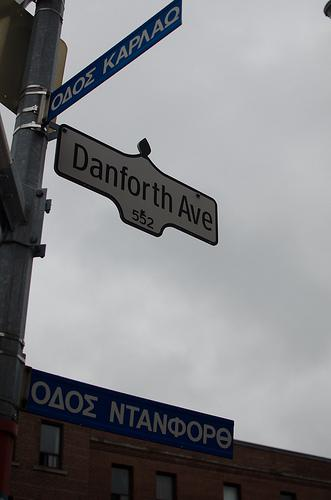Question: how many signs are there?
Choices:
A. One.
B. Two.
C. Three.
D. Four.
Answer with the letter. Answer: C Question: what number is under danforth ave?
Choices:
A. 250.
B. 361.
C. 489.
D. 552.
Answer with the letter. Answer: D Question: where are the signs?
Choices:
A. Above the door.
B. On the pole.
C. In the window.
D. On the highway.
Answer with the letter. Answer: B Question: what is in the background?
Choices:
A. A bridge.
B. A building.
C. A river.
D. A tree.
Answer with the letter. Answer: B Question: what color is the pole?
Choices:
A. Black.
B. Red.
C. Silver.
D. Blue.
Answer with the letter. Answer: C Question: how many windows are in the background?
Choices:
A. One.
B. Two.
C. Four.
D. Three.
Answer with the letter. Answer: C 